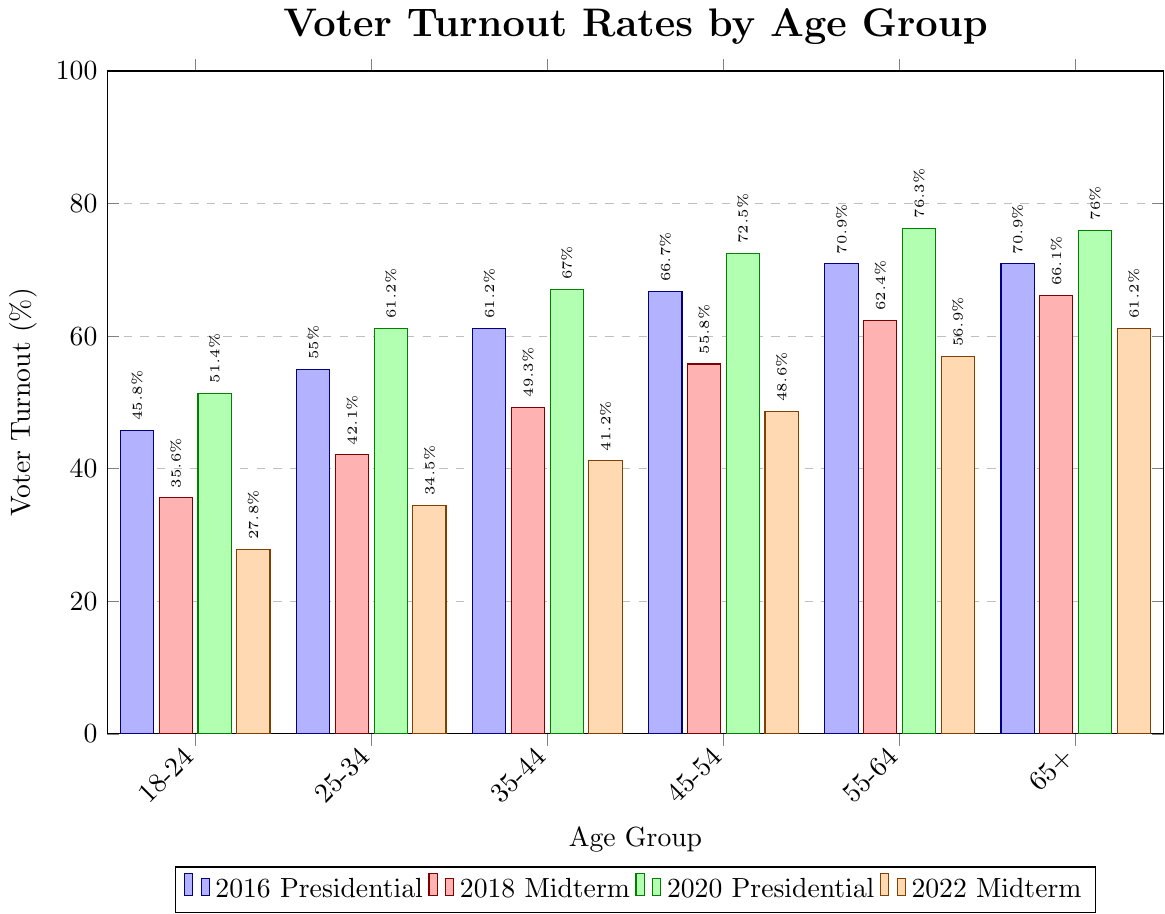What is the voter turnout rate for the 35-44 age group in the 2020 Presidential election? Look at the bar corresponding to the 35-44 age group for the green color (2020 Presidential). The height marks 67.0%.
Answer: 67.0% Which age group had the lowest voter turnout in the 2022 Midterm election? Identify the shortest bar in the orange color (2022 Midterm), which corresponds to the 18-24 age group with a turnout rate of 27.8%.
Answer: 18-24 Between the 2016 Presidential and 2020 Presidential elections, which age group saw the highest increase in voter turnout? Calculate the difference in turnout for each age group between 2016 (blue) and 2020 (green). Compare changes: 18-24 (51.4%-45.8%=5.6%), 25-34 (61.2%-55.0%=6.2%), 35-44 (67.0%-61.2%=5.8%), 45-54 (72.5%-66.7%=5.8%), 55-64 (76.3%-70.9%=5.4%), 65+ (76.0%-70.9%=5.1%). The 25-34 group saw the highest increase.
Answer: 25-34 What is the average voter turnout across all age groups for the 2018 Midterm election? Sum the values for the 2018 Midterm across all age groups and divide by 6. Calculation: (35.6 + 42.1 + 49.3 + 55.8 + 62.4 + 66.1) / 6 = 51.88%.
Answer: 51.88% Which age group had approximately equal voter turnout rates in the 2016 and 2018 elections? Compare bars within age groups for the blue (2016) and red (2018) colors. The 65+ group has 70.9% (2016) and 66.1% (2018), which are close values.
Answer: 65+ What is the difference in voter turnout rate between the 45-54 age group and the 65+ age group in the 2020 Presidential election? Subtract the turnout rate for the 65+ group from the 45-54 group in the green bars (2020 Presidential): 76.0% - 72.5% = 3.5%.
Answer: 3.5% In which election did the 55-64 age group have the highest voter turnout? Look at the highest bar for the 55-64 age group across all colors; the highest is in the 2020 Presidential (green) with 76.3%.
Answer: 2020 Presidential What is the total voter turnout percentage for the 25-34 age group over all four elections? Add the turnout percentages for the 25-34 age group across all elections: 55.0% + 42.1% + 61.2% + 34.5% = 192.8%.
Answer: 192.8% Which election saw the largest drop in voter turnout for the 18-24 age group compared to the previous election? Compare percentages for the 18-24 age group across sequential elections and find the largest drop: 2020 (51.4%) to 2022 (27.8%) = 23.6%.
Answer: 2022 Midterm 